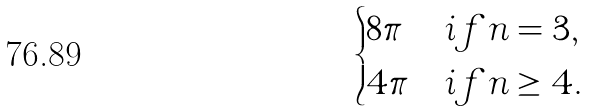Convert formula to latex. <formula><loc_0><loc_0><loc_500><loc_500>\begin{cases} 8 \pi & i f n = 3 , \\ 4 \pi & i f n \geq 4 . \end{cases}</formula> 